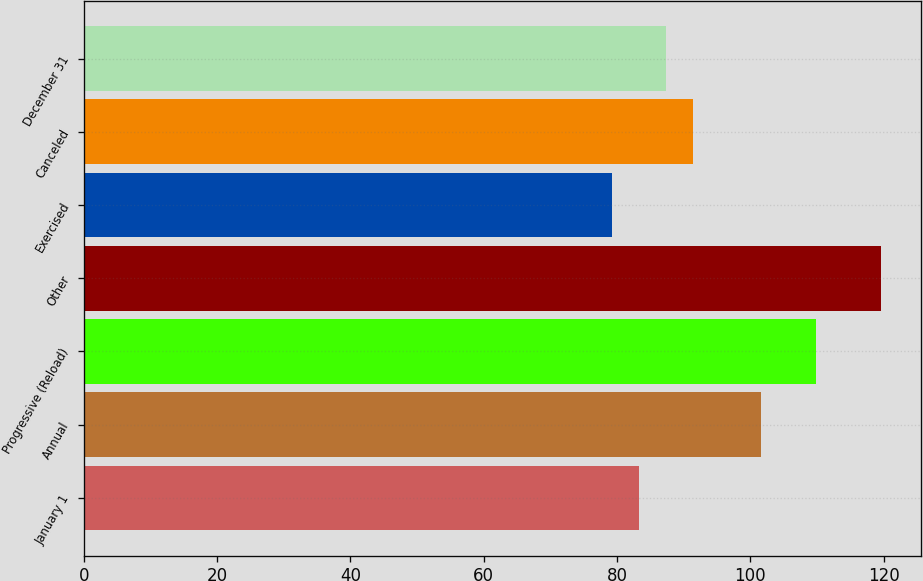Convert chart to OTSL. <chart><loc_0><loc_0><loc_500><loc_500><bar_chart><fcel>January 1<fcel>Annual<fcel>Progressive (Reload)<fcel>Other<fcel>Exercised<fcel>Canceled<fcel>December 31<nl><fcel>83.29<fcel>101.55<fcel>109.83<fcel>119.62<fcel>79.25<fcel>91.37<fcel>87.33<nl></chart> 